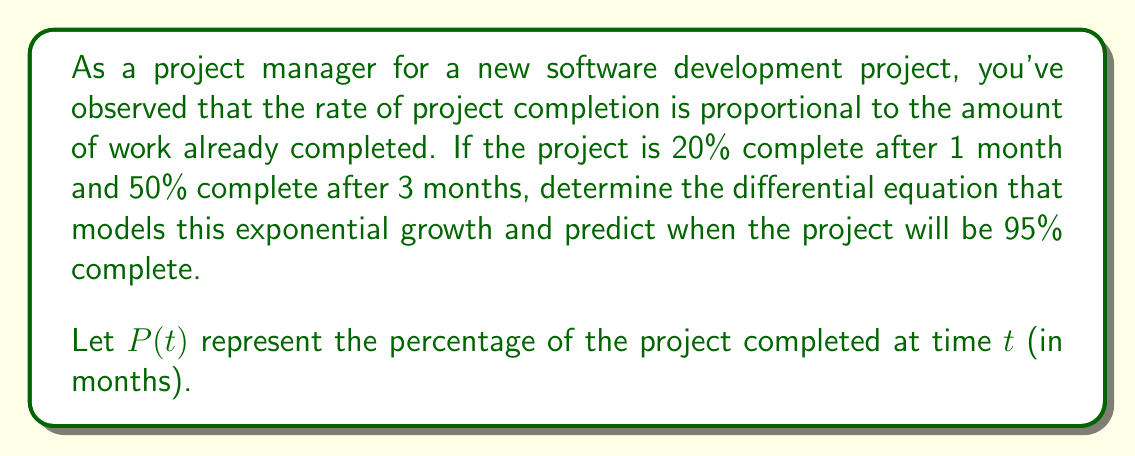Show me your answer to this math problem. To solve this problem, we'll follow these steps:

1) First, we need to set up the differential equation. The rate of change is proportional to the current value, so we have:

   $$\frac{dP}{dt} = kP$$

   where $k$ is the growth constant.

2) The general solution to this differential equation is:

   $$P(t) = Ce^{kt}$$

   where $C$ is a constant we need to determine.

3) We can use the given information to find $k$ and $C$. We know:

   At $t = 1$, $P = 20\%$ or $0.2$
   At $t = 3$, $P = 50\%$ or $0.5$

4) Substituting these into our general solution:

   $$0.2 = Ce^k$$
   $$0.5 = Ce^{3k}$$

5) Dividing the second equation by the first:

   $$\frac{0.5}{0.2} = \frac{Ce^{3k}}{Ce^k} = e^{2k}$$

6) Taking the natural log of both sides:

   $$\ln(2.5) = 2k$$
   $$k = \frac{\ln(2.5)}{2} \approx 0.4581$$

7) Now we can find $C$ using either of the original equations:

   $$0.2 = Ce^{0.4581}$$
   $$C = \frac{0.2}{e^{0.4581}} \approx 0.1268$$

8) Our complete model is therefore:

   $$P(t) = 0.1268e^{0.4581t}$$

9) To find when the project will be 95% complete, we solve:

   $$0.95 = 0.1268e^{0.4581t}$$
   $$\ln(0.95/0.1268) = 0.4581t$$
   $$t = \frac{\ln(0.95/0.1268)}{0.4581} \approx 4.92$$
Answer: The differential equation modeling the project completion is:

$$\frac{dP}{dt} = 0.4581P$$

The project will be 95% complete after approximately 4.92 months. 